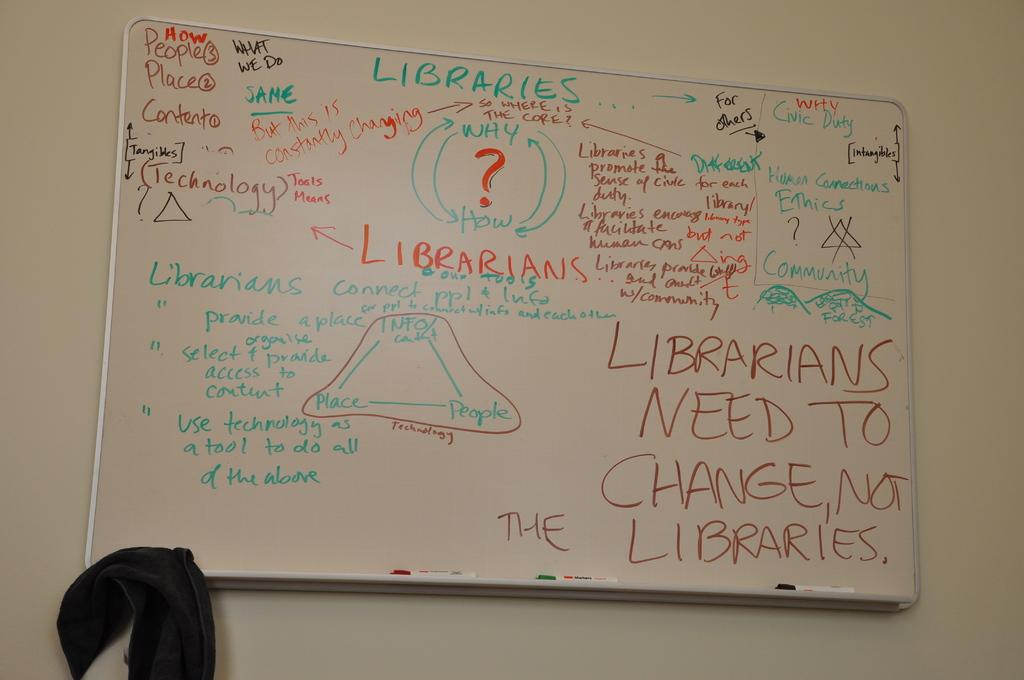<image>
Provide a brief description of the given image. A white board with writing on it about libraries says that Librarians need to change. 